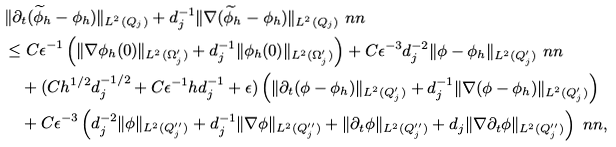<formula> <loc_0><loc_0><loc_500><loc_500>& \| \partial _ { t } ( \widetilde { \phi } _ { h } - \phi _ { h } ) \| _ { L ^ { 2 } ( Q _ { j } ) } + d _ { j } ^ { - 1 } \| \nabla ( \widetilde { \phi } _ { h } - \phi _ { h } ) \| _ { L ^ { 2 } ( Q _ { j } ) } \ n n \\ & \leq C \epsilon ^ { - 1 } \left ( \| \nabla \phi _ { h } ( 0 ) \| _ { L ^ { 2 } ( \Omega _ { j } ^ { \prime } ) } + d _ { j } ^ { - 1 } \| \phi _ { h } ( 0 ) \| _ { L ^ { 2 } ( \Omega _ { j } ^ { \prime } ) } \right ) + C \epsilon ^ { - 3 } d _ { j } ^ { - 2 } \| \phi - \phi _ { h } \| _ { L ^ { 2 } ( Q _ { j } ^ { \prime } ) } \ n n \\ & \quad + ( C h ^ { 1 / 2 } d _ { j } ^ { - 1 / 2 } + C \epsilon ^ { - 1 } h d _ { j } ^ { - 1 } + \epsilon ) \left ( \| \partial _ { t } ( \phi - \phi _ { h } ) \| _ { L ^ { 2 } ( Q _ { j } ^ { \prime } ) } + d _ { j } ^ { - 1 } \| \nabla ( \phi - \phi _ { h } ) \| _ { L ^ { 2 } ( Q _ { j } ^ { \prime } ) } \right ) \\ & \quad + C \epsilon ^ { - 3 } \left ( d _ { j } ^ { - 2 } \| \phi \| _ { L ^ { 2 } ( Q _ { j } ^ { \prime \prime } ) } + d _ { j } ^ { - 1 } \| \nabla \phi \| _ { L ^ { 2 } ( Q _ { j } ^ { \prime \prime } ) } + \| \partial _ { t } \phi \| _ { L ^ { 2 } ( Q _ { j } ^ { \prime \prime } ) } + d _ { j } \| \nabla \partial _ { t } \phi \| _ { L ^ { 2 } ( Q _ { j } ^ { \prime \prime } ) } \right ) \ n n ,</formula> 